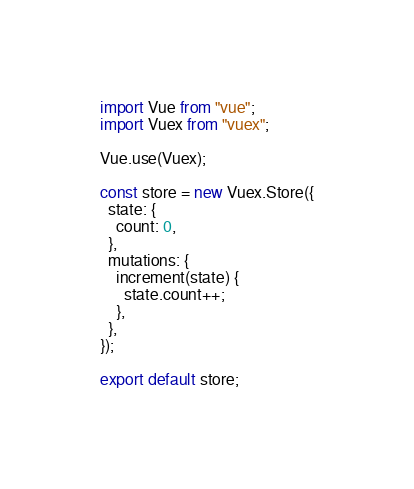<code> <loc_0><loc_0><loc_500><loc_500><_JavaScript_>import Vue from "vue";
import Vuex from "vuex";

Vue.use(Vuex);

const store = new Vuex.Store({
  state: {
    count: 0,
  },
  mutations: {
    increment(state) {
      state.count++;
    },
  },
});

export default store;
</code> 